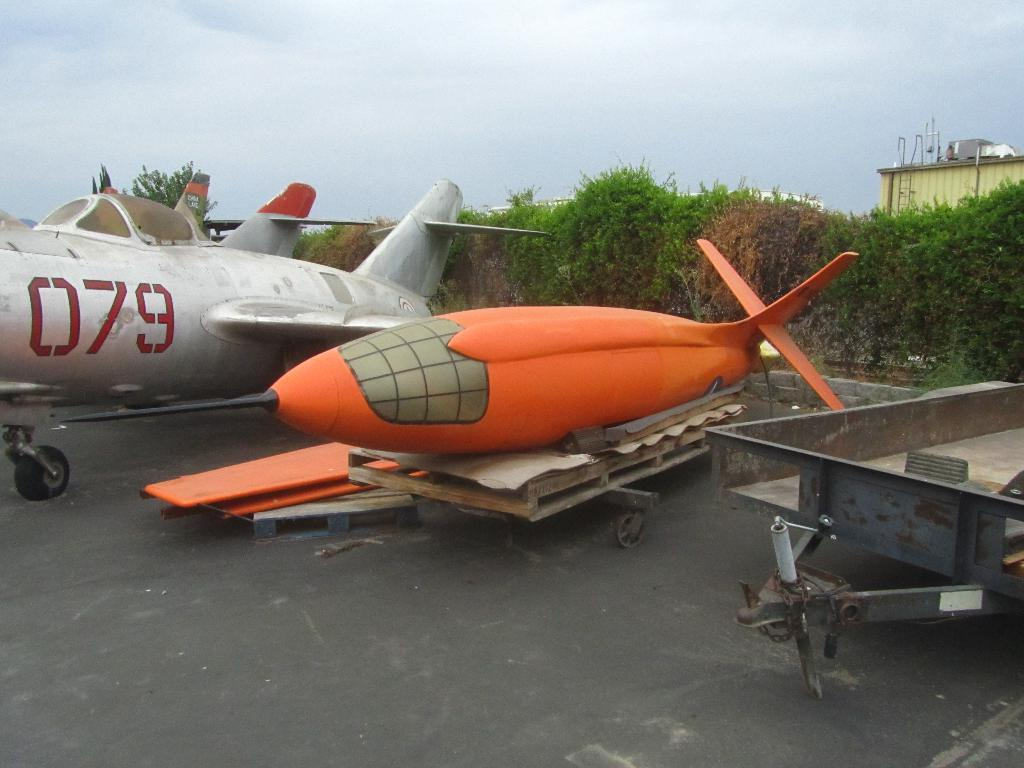<image>
Create a compact narrative representing the image presented. A small orange aircraft that has its wings detached is laying on a trailer next to a plane with the numbers 079 on it. 